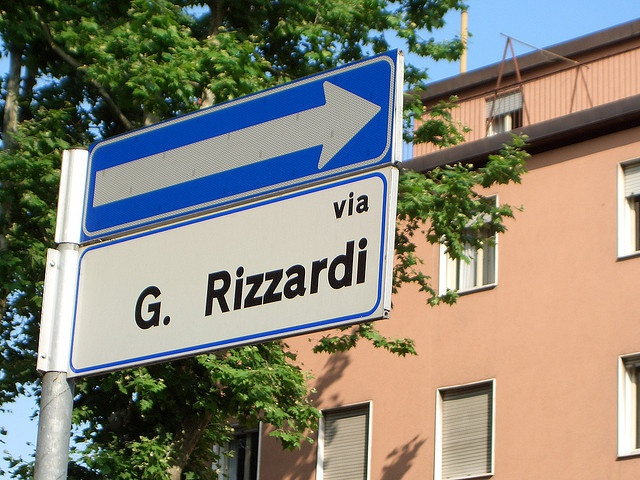Describe the objects in this image and their specific colors. I can see various objects in this image with different colors. 